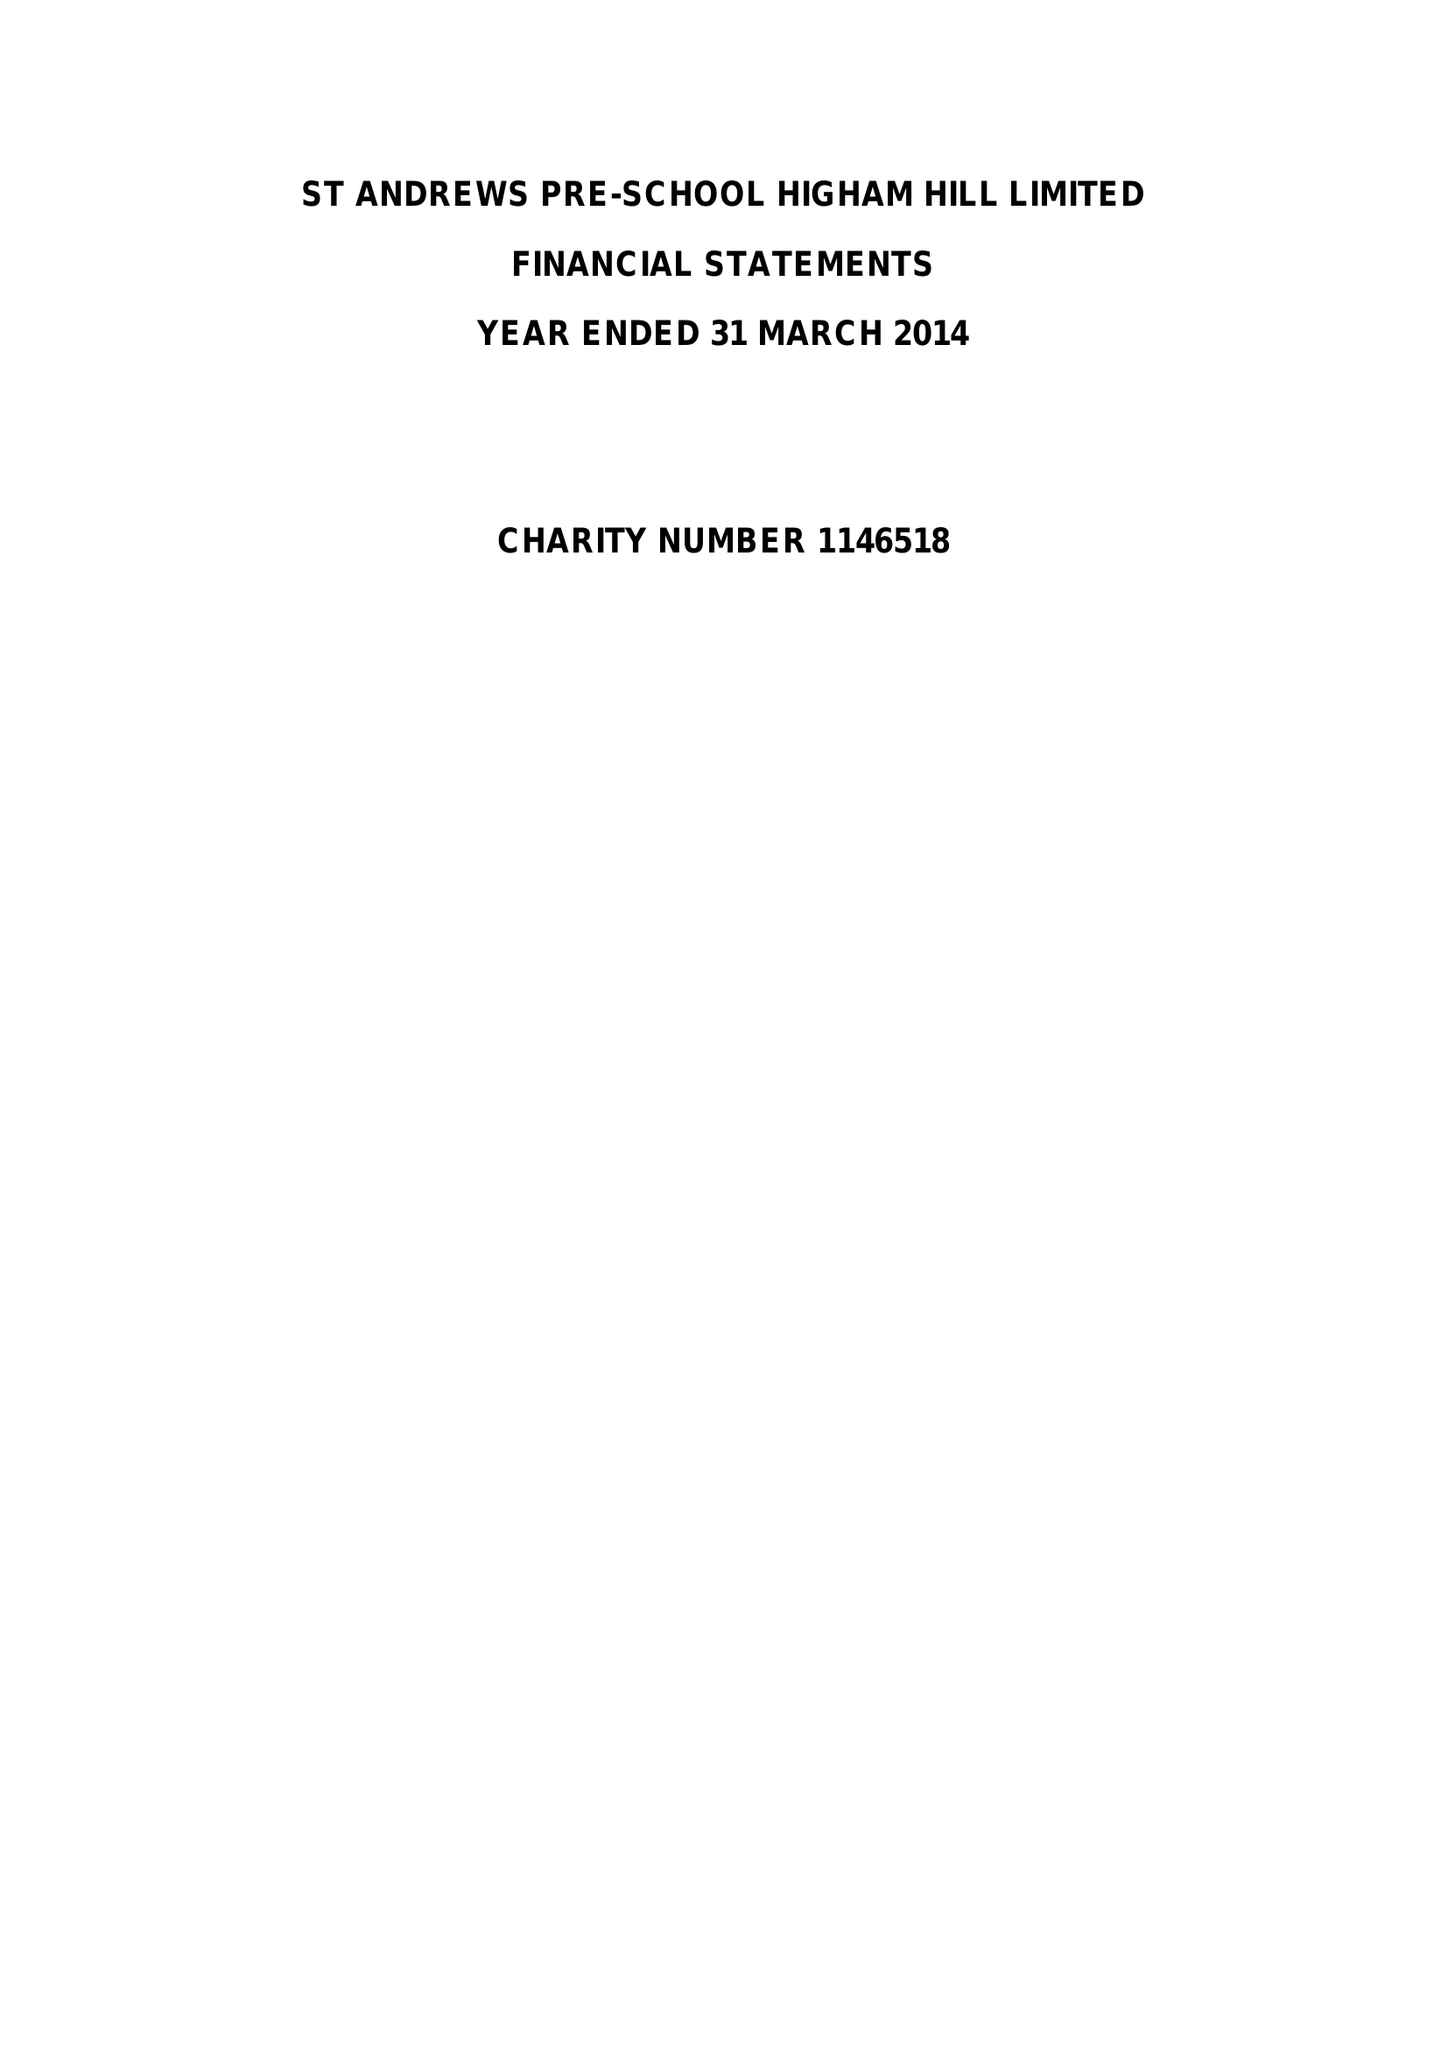What is the value for the charity_number?
Answer the question using a single word or phrase. 1146518 